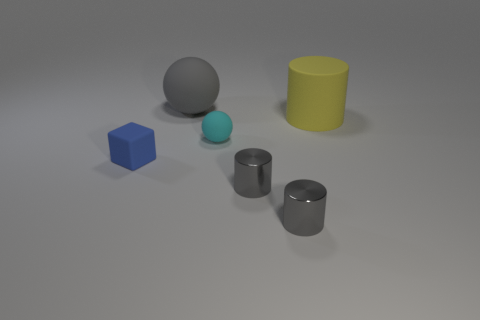There is a thing that is both behind the tiny cyan matte object and on the right side of the gray ball; what color is it?
Make the answer very short. Yellow. What material is the small thing behind the tiny rubber object that is to the left of the gray thing that is behind the yellow matte cylinder?
Ensure brevity in your answer.  Rubber. What is the size of the gray object that is the same shape as the cyan object?
Offer a terse response. Large. Does the block have the same color as the tiny rubber ball?
Offer a very short reply. No. What number of other objects are the same material as the yellow cylinder?
Provide a succinct answer. 3. Are there the same number of large gray rubber things right of the large yellow cylinder and big red rubber cubes?
Make the answer very short. Yes. There is a ball that is in front of the yellow rubber object; is its size the same as the tiny matte block?
Offer a very short reply. Yes. There is a cyan rubber object; how many large yellow cylinders are right of it?
Your answer should be compact. 1. What is the material of the thing that is both to the right of the large rubber ball and behind the cyan rubber thing?
Your answer should be very brief. Rubber. How many big objects are either brown blocks or yellow objects?
Keep it short and to the point. 1. 